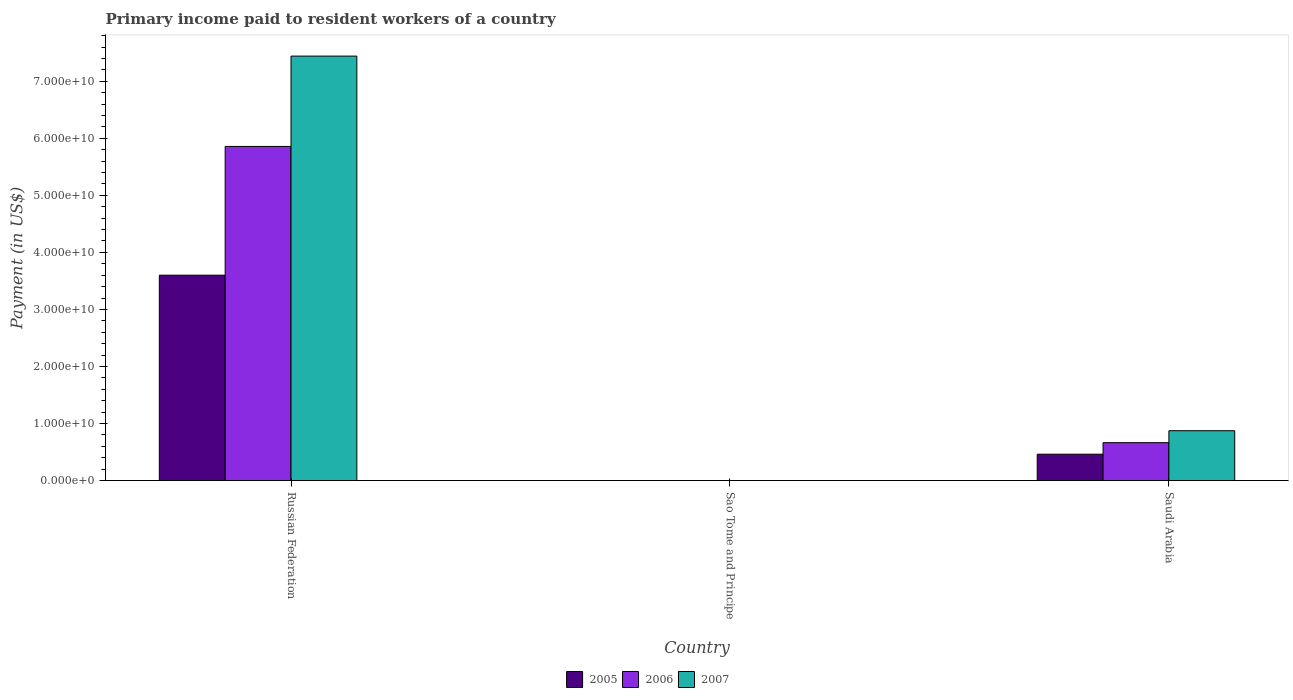How many different coloured bars are there?
Give a very brief answer. 3. How many groups of bars are there?
Offer a terse response. 3. Are the number of bars on each tick of the X-axis equal?
Provide a short and direct response. Yes. How many bars are there on the 3rd tick from the left?
Your answer should be very brief. 3. How many bars are there on the 3rd tick from the right?
Provide a succinct answer. 3. What is the label of the 2nd group of bars from the left?
Make the answer very short. Sao Tome and Principe. What is the amount paid to workers in 2006 in Russian Federation?
Keep it short and to the point. 5.86e+1. Across all countries, what is the maximum amount paid to workers in 2007?
Ensure brevity in your answer.  7.44e+1. Across all countries, what is the minimum amount paid to workers in 2005?
Provide a succinct answer. 4.90e+06. In which country was the amount paid to workers in 2005 maximum?
Ensure brevity in your answer.  Russian Federation. In which country was the amount paid to workers in 2007 minimum?
Give a very brief answer. Sao Tome and Principe. What is the total amount paid to workers in 2007 in the graph?
Give a very brief answer. 8.32e+1. What is the difference between the amount paid to workers in 2006 in Russian Federation and that in Sao Tome and Principe?
Ensure brevity in your answer.  5.86e+1. What is the difference between the amount paid to workers in 2006 in Sao Tome and Principe and the amount paid to workers in 2005 in Russian Federation?
Ensure brevity in your answer.  -3.60e+1. What is the average amount paid to workers in 2005 per country?
Your answer should be compact. 1.35e+1. What is the difference between the amount paid to workers of/in 2007 and amount paid to workers of/in 2005 in Russian Federation?
Provide a succinct answer. 3.84e+1. In how many countries, is the amount paid to workers in 2007 greater than 36000000000 US$?
Give a very brief answer. 1. What is the ratio of the amount paid to workers in 2005 in Sao Tome and Principe to that in Saudi Arabia?
Provide a short and direct response. 0. Is the amount paid to workers in 2005 in Sao Tome and Principe less than that in Saudi Arabia?
Provide a short and direct response. Yes. Is the difference between the amount paid to workers in 2007 in Russian Federation and Saudi Arabia greater than the difference between the amount paid to workers in 2005 in Russian Federation and Saudi Arabia?
Offer a very short reply. Yes. What is the difference between the highest and the second highest amount paid to workers in 2006?
Your answer should be very brief. 5.86e+1. What is the difference between the highest and the lowest amount paid to workers in 2006?
Give a very brief answer. 5.86e+1. In how many countries, is the amount paid to workers in 2005 greater than the average amount paid to workers in 2005 taken over all countries?
Ensure brevity in your answer.  1. Is the sum of the amount paid to workers in 2007 in Russian Federation and Saudi Arabia greater than the maximum amount paid to workers in 2005 across all countries?
Provide a succinct answer. Yes. What does the 3rd bar from the left in Russian Federation represents?
Give a very brief answer. 2007. How many bars are there?
Provide a succinct answer. 9. Are all the bars in the graph horizontal?
Give a very brief answer. No. How many countries are there in the graph?
Offer a terse response. 3. What is the difference between two consecutive major ticks on the Y-axis?
Your answer should be compact. 1.00e+1. Are the values on the major ticks of Y-axis written in scientific E-notation?
Offer a terse response. Yes. Does the graph contain any zero values?
Your response must be concise. No. Where does the legend appear in the graph?
Provide a succinct answer. Bottom center. How many legend labels are there?
Provide a succinct answer. 3. How are the legend labels stacked?
Ensure brevity in your answer.  Horizontal. What is the title of the graph?
Provide a succinct answer. Primary income paid to resident workers of a country. Does "1979" appear as one of the legend labels in the graph?
Offer a very short reply. No. What is the label or title of the Y-axis?
Your response must be concise. Payment (in US$). What is the Payment (in US$) in 2005 in Russian Federation?
Make the answer very short. 3.60e+1. What is the Payment (in US$) of 2006 in Russian Federation?
Make the answer very short. 5.86e+1. What is the Payment (in US$) of 2007 in Russian Federation?
Keep it short and to the point. 7.44e+1. What is the Payment (in US$) in 2005 in Sao Tome and Principe?
Keep it short and to the point. 4.90e+06. What is the Payment (in US$) of 2006 in Sao Tome and Principe?
Your answer should be very brief. 3.12e+06. What is the Payment (in US$) of 2007 in Sao Tome and Principe?
Your answer should be compact. 2.29e+06. What is the Payment (in US$) in 2005 in Saudi Arabia?
Your response must be concise. 4.63e+09. What is the Payment (in US$) of 2006 in Saudi Arabia?
Make the answer very short. 6.65e+09. What is the Payment (in US$) in 2007 in Saudi Arabia?
Your answer should be very brief. 8.74e+09. Across all countries, what is the maximum Payment (in US$) in 2005?
Your response must be concise. 3.60e+1. Across all countries, what is the maximum Payment (in US$) in 2006?
Provide a succinct answer. 5.86e+1. Across all countries, what is the maximum Payment (in US$) in 2007?
Ensure brevity in your answer.  7.44e+1. Across all countries, what is the minimum Payment (in US$) in 2005?
Provide a succinct answer. 4.90e+06. Across all countries, what is the minimum Payment (in US$) in 2006?
Provide a succinct answer. 3.12e+06. Across all countries, what is the minimum Payment (in US$) of 2007?
Offer a very short reply. 2.29e+06. What is the total Payment (in US$) of 2005 in the graph?
Your answer should be very brief. 4.06e+1. What is the total Payment (in US$) in 2006 in the graph?
Your response must be concise. 6.52e+1. What is the total Payment (in US$) in 2007 in the graph?
Provide a short and direct response. 8.32e+1. What is the difference between the Payment (in US$) of 2005 in Russian Federation and that in Sao Tome and Principe?
Offer a very short reply. 3.60e+1. What is the difference between the Payment (in US$) of 2006 in Russian Federation and that in Sao Tome and Principe?
Give a very brief answer. 5.86e+1. What is the difference between the Payment (in US$) of 2007 in Russian Federation and that in Sao Tome and Principe?
Provide a succinct answer. 7.44e+1. What is the difference between the Payment (in US$) of 2005 in Russian Federation and that in Saudi Arabia?
Offer a terse response. 3.14e+1. What is the difference between the Payment (in US$) in 2006 in Russian Federation and that in Saudi Arabia?
Provide a succinct answer. 5.19e+1. What is the difference between the Payment (in US$) in 2007 in Russian Federation and that in Saudi Arabia?
Your answer should be very brief. 6.57e+1. What is the difference between the Payment (in US$) in 2005 in Sao Tome and Principe and that in Saudi Arabia?
Your response must be concise. -4.62e+09. What is the difference between the Payment (in US$) in 2006 in Sao Tome and Principe and that in Saudi Arabia?
Provide a short and direct response. -6.64e+09. What is the difference between the Payment (in US$) in 2007 in Sao Tome and Principe and that in Saudi Arabia?
Keep it short and to the point. -8.74e+09. What is the difference between the Payment (in US$) of 2005 in Russian Federation and the Payment (in US$) of 2006 in Sao Tome and Principe?
Your response must be concise. 3.60e+1. What is the difference between the Payment (in US$) of 2005 in Russian Federation and the Payment (in US$) of 2007 in Sao Tome and Principe?
Give a very brief answer. 3.60e+1. What is the difference between the Payment (in US$) in 2006 in Russian Federation and the Payment (in US$) in 2007 in Sao Tome and Principe?
Ensure brevity in your answer.  5.86e+1. What is the difference between the Payment (in US$) of 2005 in Russian Federation and the Payment (in US$) of 2006 in Saudi Arabia?
Make the answer very short. 2.94e+1. What is the difference between the Payment (in US$) in 2005 in Russian Federation and the Payment (in US$) in 2007 in Saudi Arabia?
Ensure brevity in your answer.  2.73e+1. What is the difference between the Payment (in US$) of 2006 in Russian Federation and the Payment (in US$) of 2007 in Saudi Arabia?
Your response must be concise. 4.98e+1. What is the difference between the Payment (in US$) of 2005 in Sao Tome and Principe and the Payment (in US$) of 2006 in Saudi Arabia?
Offer a terse response. -6.64e+09. What is the difference between the Payment (in US$) in 2005 in Sao Tome and Principe and the Payment (in US$) in 2007 in Saudi Arabia?
Make the answer very short. -8.74e+09. What is the difference between the Payment (in US$) of 2006 in Sao Tome and Principe and the Payment (in US$) of 2007 in Saudi Arabia?
Provide a short and direct response. -8.74e+09. What is the average Payment (in US$) in 2005 per country?
Provide a short and direct response. 1.35e+1. What is the average Payment (in US$) of 2006 per country?
Offer a very short reply. 2.17e+1. What is the average Payment (in US$) in 2007 per country?
Your answer should be compact. 2.77e+1. What is the difference between the Payment (in US$) of 2005 and Payment (in US$) of 2006 in Russian Federation?
Your answer should be very brief. -2.26e+1. What is the difference between the Payment (in US$) of 2005 and Payment (in US$) of 2007 in Russian Federation?
Offer a very short reply. -3.84e+1. What is the difference between the Payment (in US$) of 2006 and Payment (in US$) of 2007 in Russian Federation?
Ensure brevity in your answer.  -1.58e+1. What is the difference between the Payment (in US$) in 2005 and Payment (in US$) in 2006 in Sao Tome and Principe?
Your answer should be very brief. 1.78e+06. What is the difference between the Payment (in US$) in 2005 and Payment (in US$) in 2007 in Sao Tome and Principe?
Your answer should be very brief. 2.61e+06. What is the difference between the Payment (in US$) of 2006 and Payment (in US$) of 2007 in Sao Tome and Principe?
Offer a terse response. 8.31e+05. What is the difference between the Payment (in US$) in 2005 and Payment (in US$) in 2006 in Saudi Arabia?
Provide a succinct answer. -2.02e+09. What is the difference between the Payment (in US$) in 2005 and Payment (in US$) in 2007 in Saudi Arabia?
Offer a terse response. -4.12e+09. What is the difference between the Payment (in US$) of 2006 and Payment (in US$) of 2007 in Saudi Arabia?
Ensure brevity in your answer.  -2.09e+09. What is the ratio of the Payment (in US$) of 2005 in Russian Federation to that in Sao Tome and Principe?
Offer a terse response. 7352.32. What is the ratio of the Payment (in US$) of 2006 in Russian Federation to that in Sao Tome and Principe?
Keep it short and to the point. 1.88e+04. What is the ratio of the Payment (in US$) of 2007 in Russian Federation to that in Sao Tome and Principe?
Offer a terse response. 3.25e+04. What is the ratio of the Payment (in US$) in 2005 in Russian Federation to that in Saudi Arabia?
Make the answer very short. 7.78. What is the ratio of the Payment (in US$) in 2006 in Russian Federation to that in Saudi Arabia?
Offer a terse response. 8.81. What is the ratio of the Payment (in US$) in 2007 in Russian Federation to that in Saudi Arabia?
Your answer should be very brief. 8.51. What is the ratio of the Payment (in US$) in 2005 in Sao Tome and Principe to that in Saudi Arabia?
Ensure brevity in your answer.  0. What is the ratio of the Payment (in US$) of 2006 in Sao Tome and Principe to that in Saudi Arabia?
Provide a short and direct response. 0. What is the difference between the highest and the second highest Payment (in US$) in 2005?
Your answer should be compact. 3.14e+1. What is the difference between the highest and the second highest Payment (in US$) of 2006?
Offer a terse response. 5.19e+1. What is the difference between the highest and the second highest Payment (in US$) in 2007?
Give a very brief answer. 6.57e+1. What is the difference between the highest and the lowest Payment (in US$) of 2005?
Your answer should be very brief. 3.60e+1. What is the difference between the highest and the lowest Payment (in US$) in 2006?
Keep it short and to the point. 5.86e+1. What is the difference between the highest and the lowest Payment (in US$) in 2007?
Your response must be concise. 7.44e+1. 